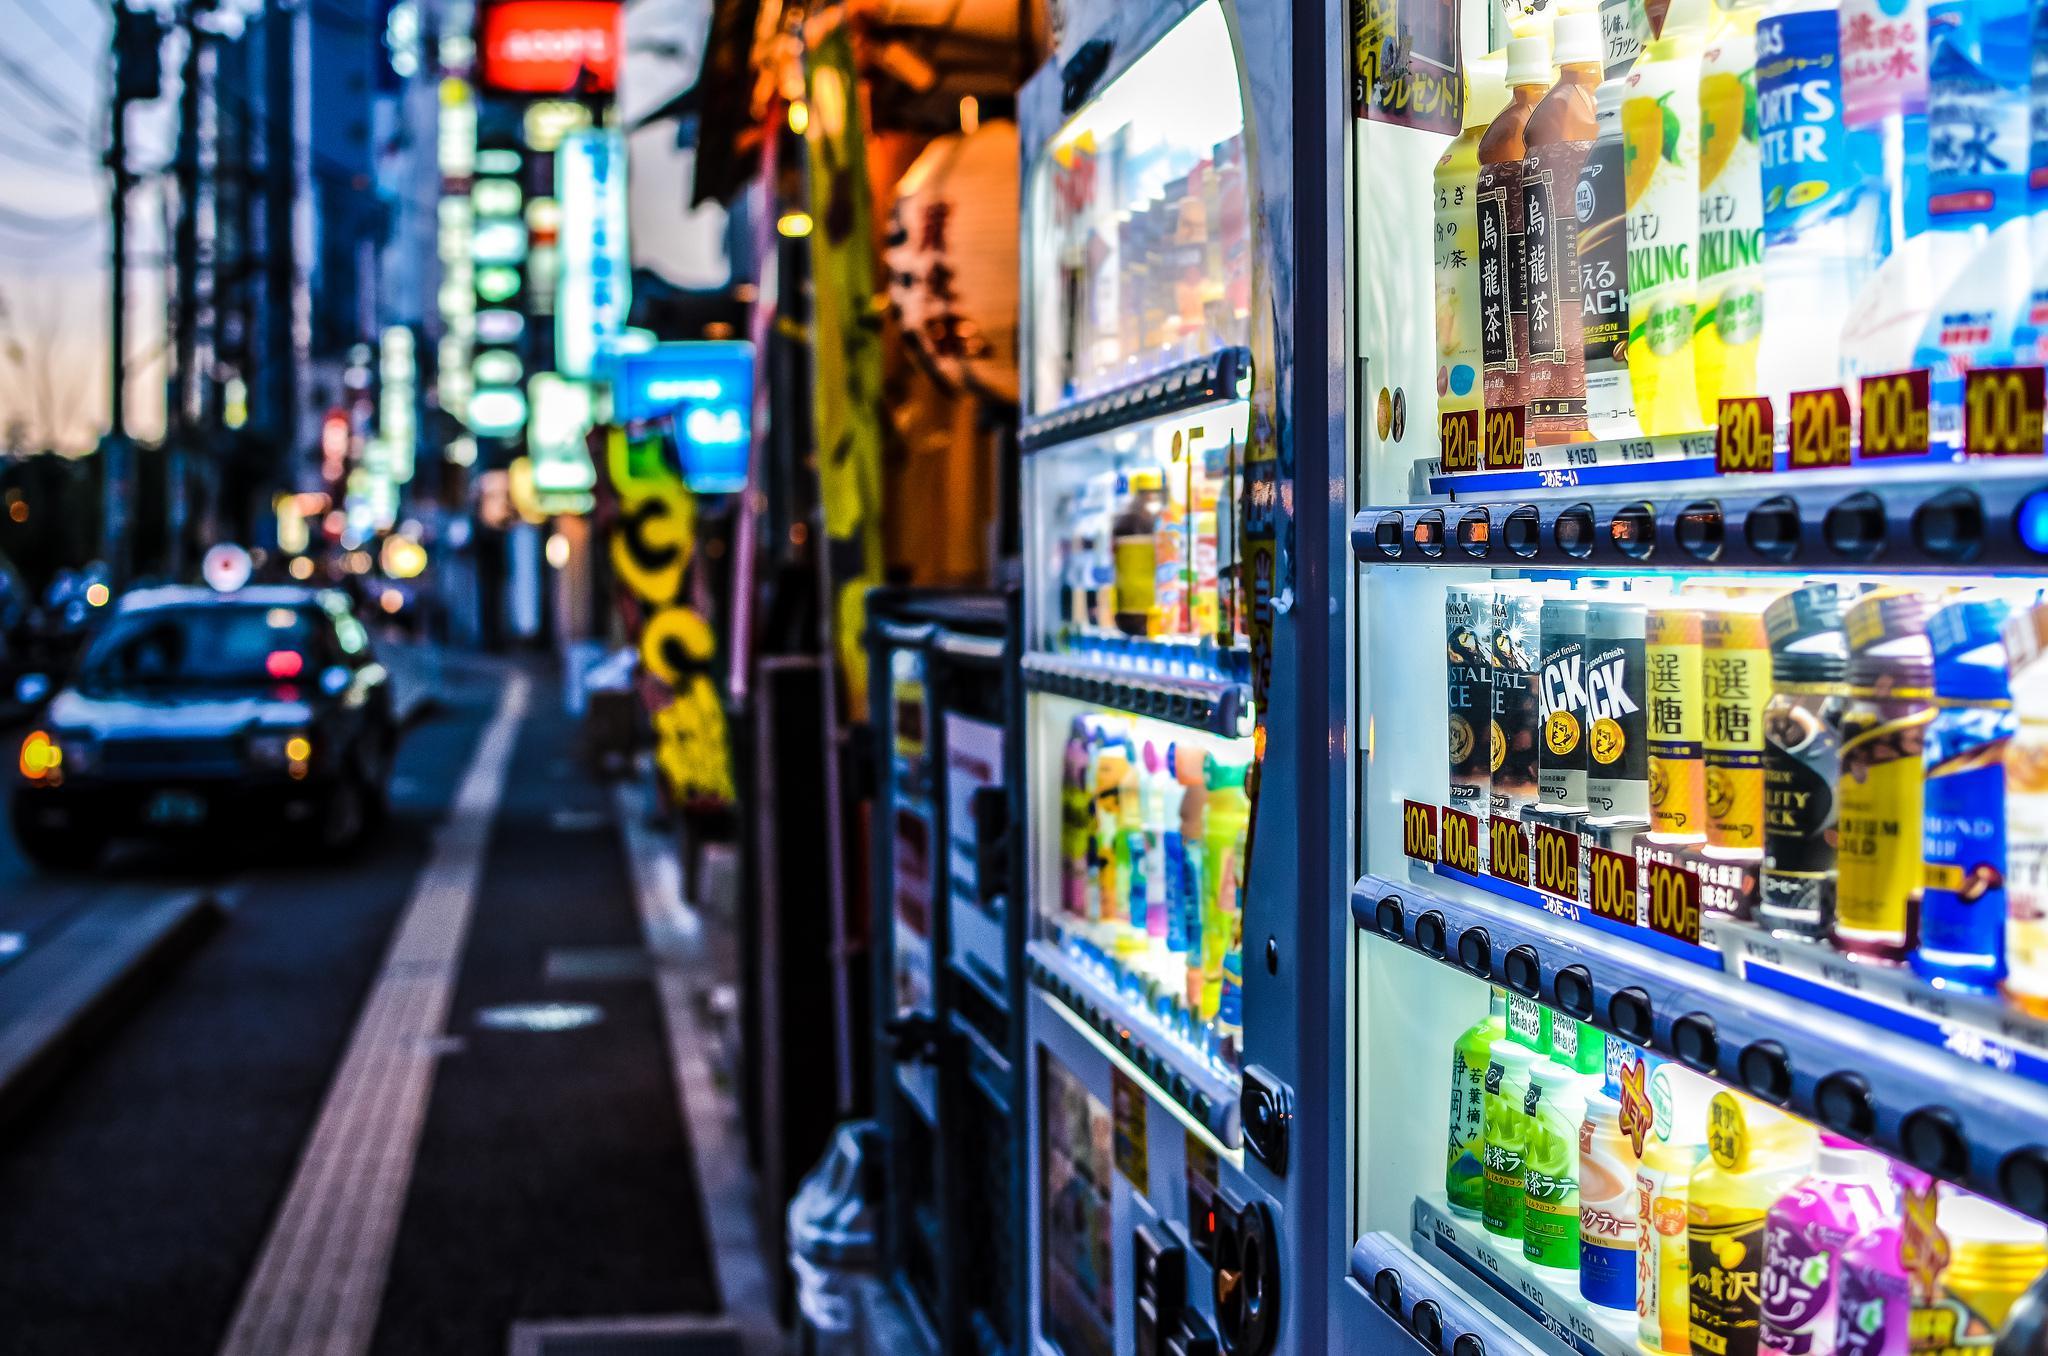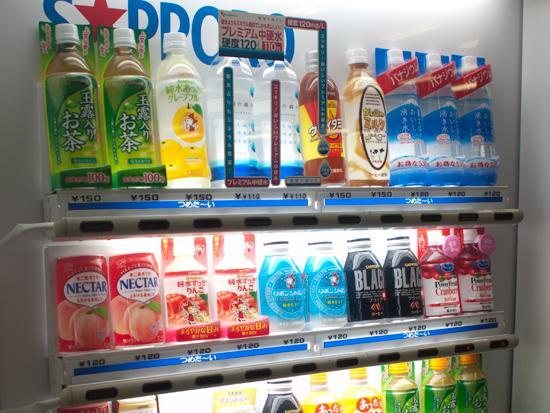The first image is the image on the left, the second image is the image on the right. For the images shown, is this caption "The image on the left features more than one vending machine." true? Answer yes or no. Yes. The first image is the image on the left, the second image is the image on the right. For the images displayed, is the sentence "An image shows the front of one vending machine, which is red and displays three rows of items." factually correct? Answer yes or no. No. 